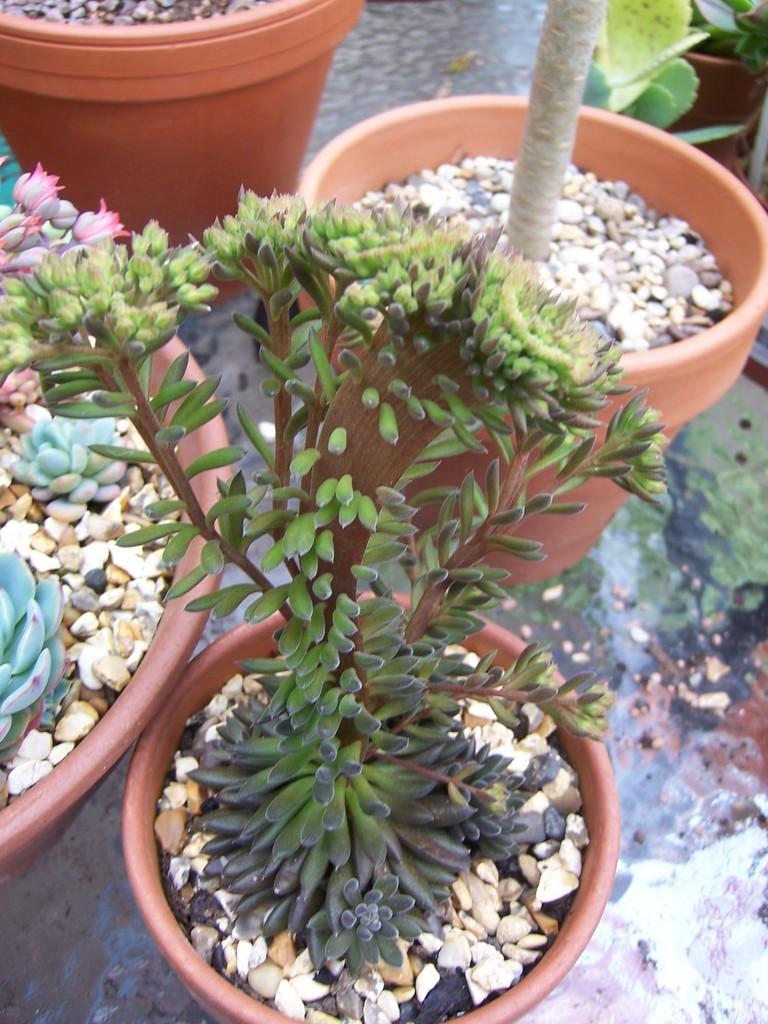In one or two sentences, can you explain what this image depicts? In this picture I can see plants in the pots and I can see few small stones in the pots. 